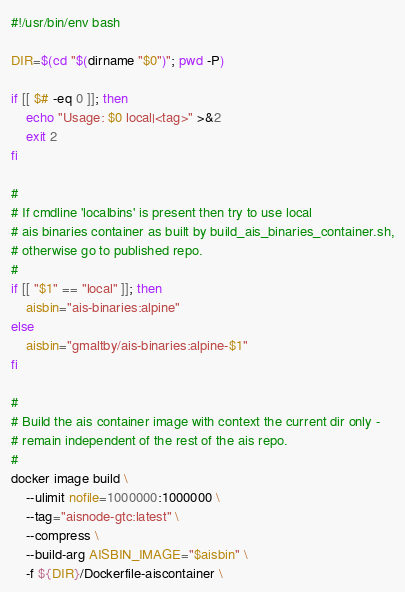Convert code to text. <code><loc_0><loc_0><loc_500><loc_500><_Bash_>#!/usr/bin/env bash

DIR=$(cd "$(dirname "$0")"; pwd -P)

if [[ $# -eq 0 ]]; then
    echo "Usage: $0 local|<tag>" >&2
    exit 2
fi

#
# If cmdline 'localbins' is present then try to use local
# ais binaries container as built by build_ais_binaries_container.sh,
# otherwise go to published repo.
#
if [[ "$1" == "local" ]]; then
    aisbin="ais-binaries:alpine"
else
    aisbin="gmaltby/ais-binaries:alpine-$1"
fi

# 
# Build the ais container image with context the current dir only -
# remain independent of the rest of the ais repo.
#
docker image build \
    --ulimit nofile=1000000:1000000 \
    --tag="aisnode-gtc:latest" \
    --compress \
    --build-arg AISBIN_IMAGE="$aisbin" \
    -f ${DIR}/Dockerfile-aiscontainer \</code> 